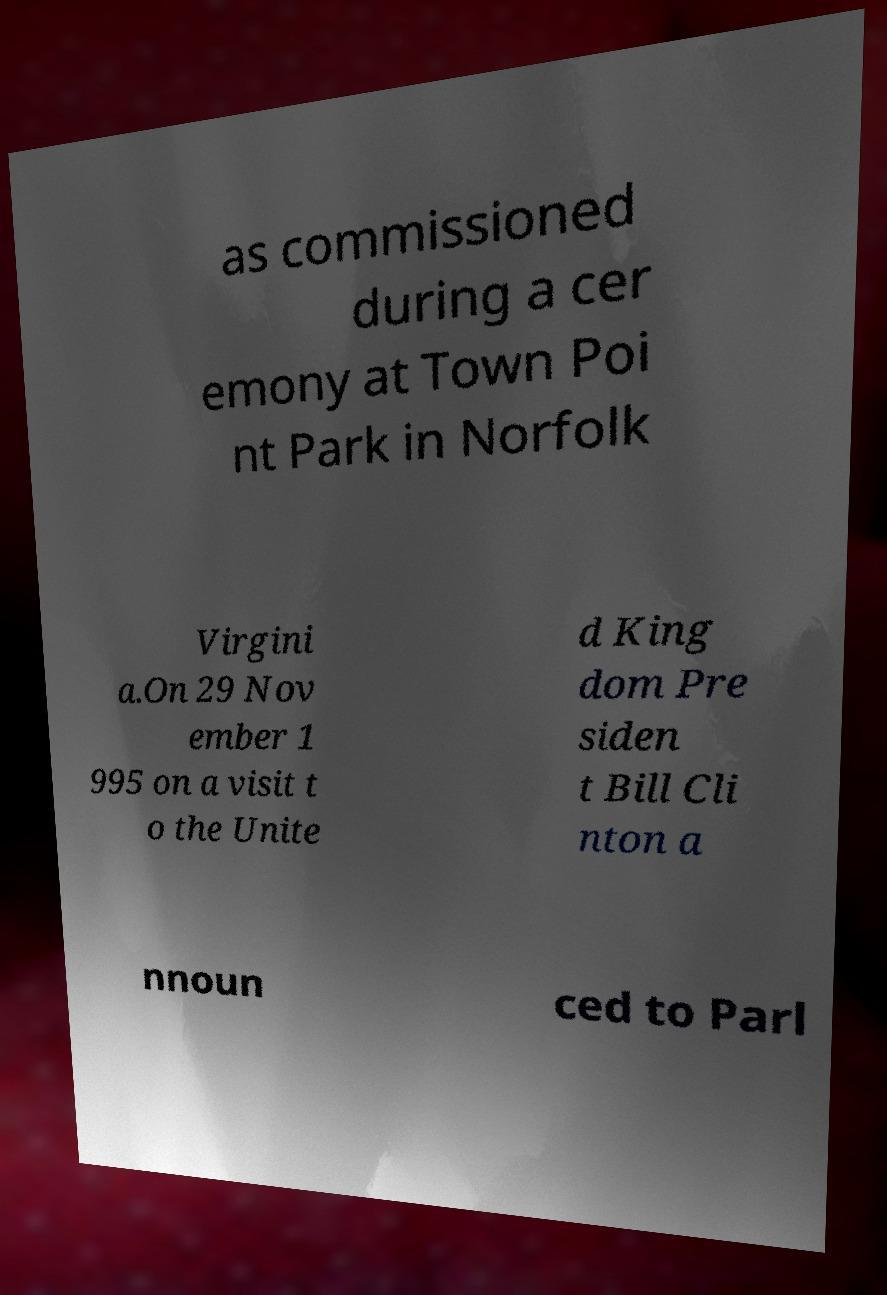Can you read and provide the text displayed in the image?This photo seems to have some interesting text. Can you extract and type it out for me? as commissioned during a cer emony at Town Poi nt Park in Norfolk Virgini a.On 29 Nov ember 1 995 on a visit t o the Unite d King dom Pre siden t Bill Cli nton a nnoun ced to Parl 